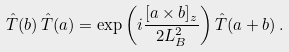Convert formula to latex. <formula><loc_0><loc_0><loc_500><loc_500>\hat { T } ( { b } ) \, \hat { T } ( { a } ) = \exp \left ( i \frac { [ { a } \times { b } ] _ { z } } { 2 L _ { B } ^ { 2 } } \right ) \hat { T } ( { a } + { b } ) \, .</formula> 